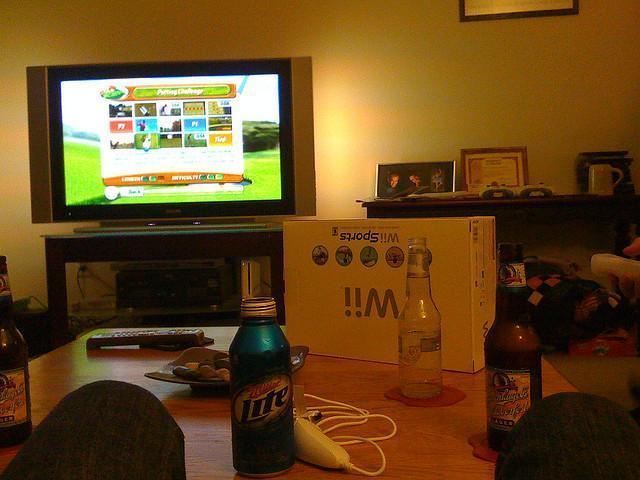How many bottles are in the photo?
Give a very brief answer. 4. How many orange cats are there in the image?
Give a very brief answer. 0. 